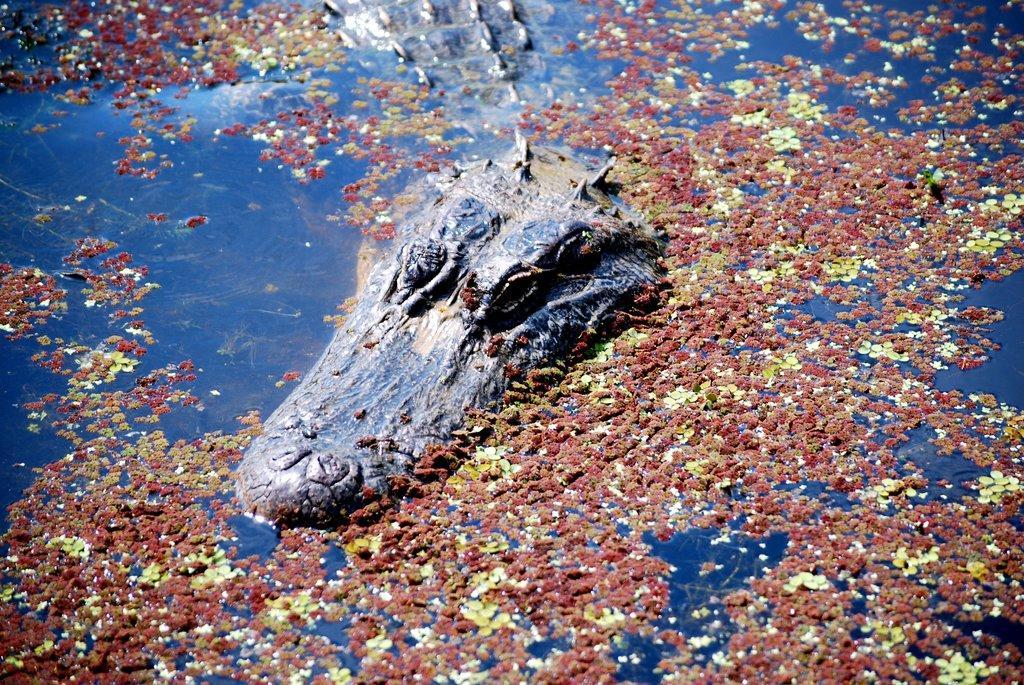Describe this image in one or two sentences. In this picture we can see an alligator in the water. Something is floating on the water. 